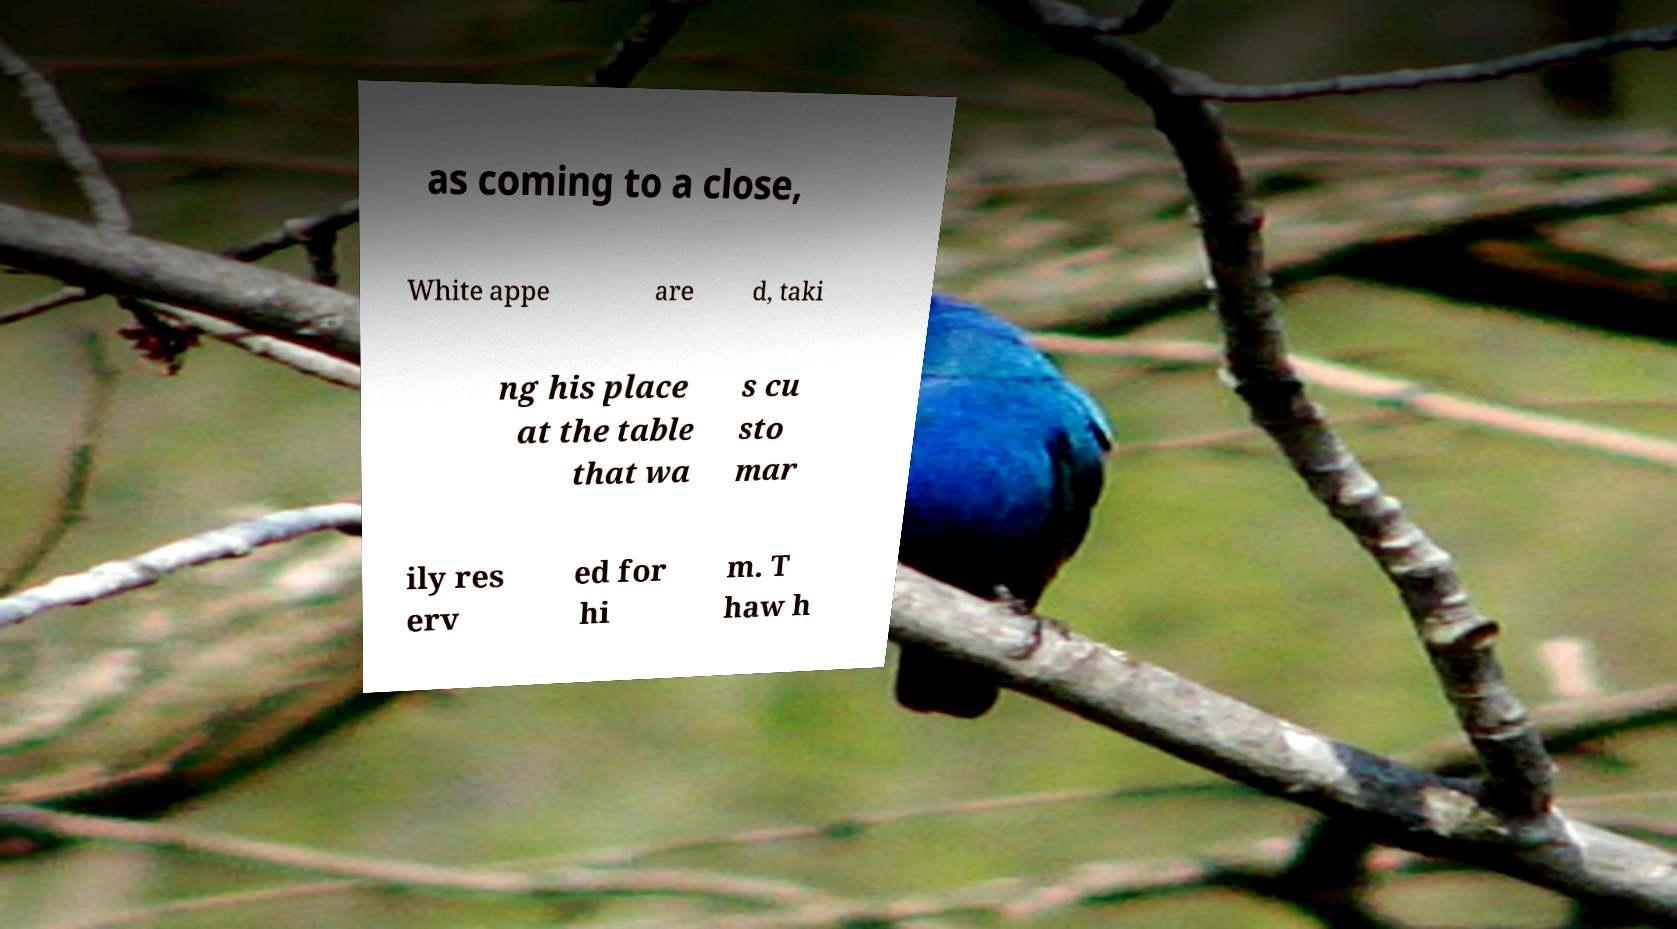There's text embedded in this image that I need extracted. Can you transcribe it verbatim? as coming to a close, White appe are d, taki ng his place at the table that wa s cu sto mar ily res erv ed for hi m. T haw h 